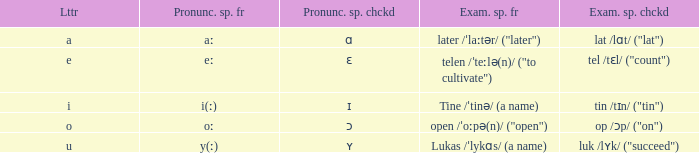What is Pronunciation Spelled Free, when Pronunciation Spelled Checked is "ɑ"? Aː. 